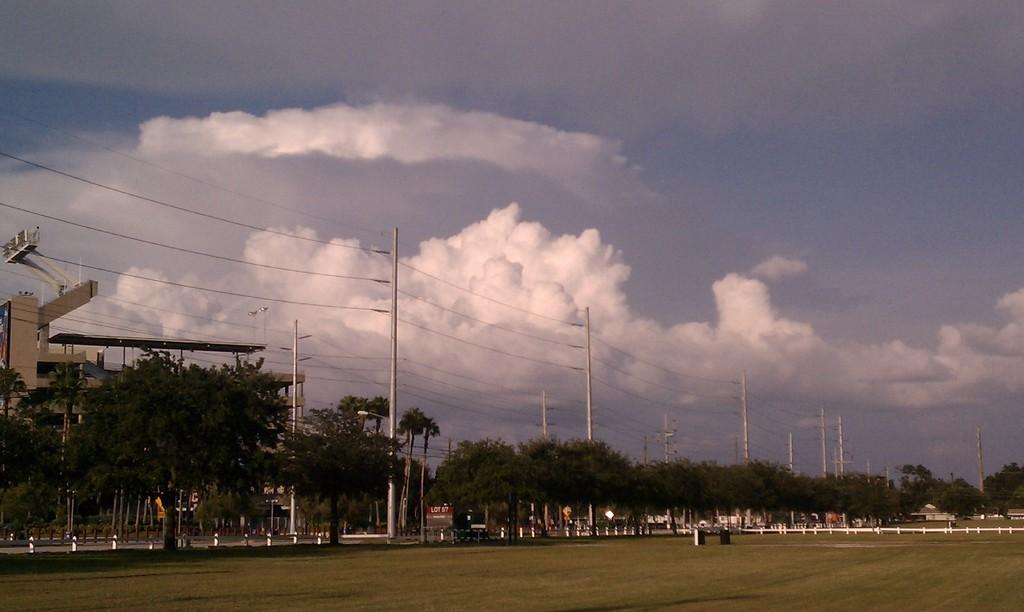Where was the image taken? The image was clicked outside. What can be seen at the bottom of the image? There is ground at the bottom of the image. What is visible in the front of the image? There are many trees and poles with wires in the front of the image. What is visible in the sky at the top of the image? There are clouds in the sky at the top of the image. What type of pollution can be seen in the image? There is no pollution visible in the image. How does the wilderness contribute to the earth in the image? The image does not depict wilderness or the earth; it shows trees, poles with wires, and clouds in the sky. 